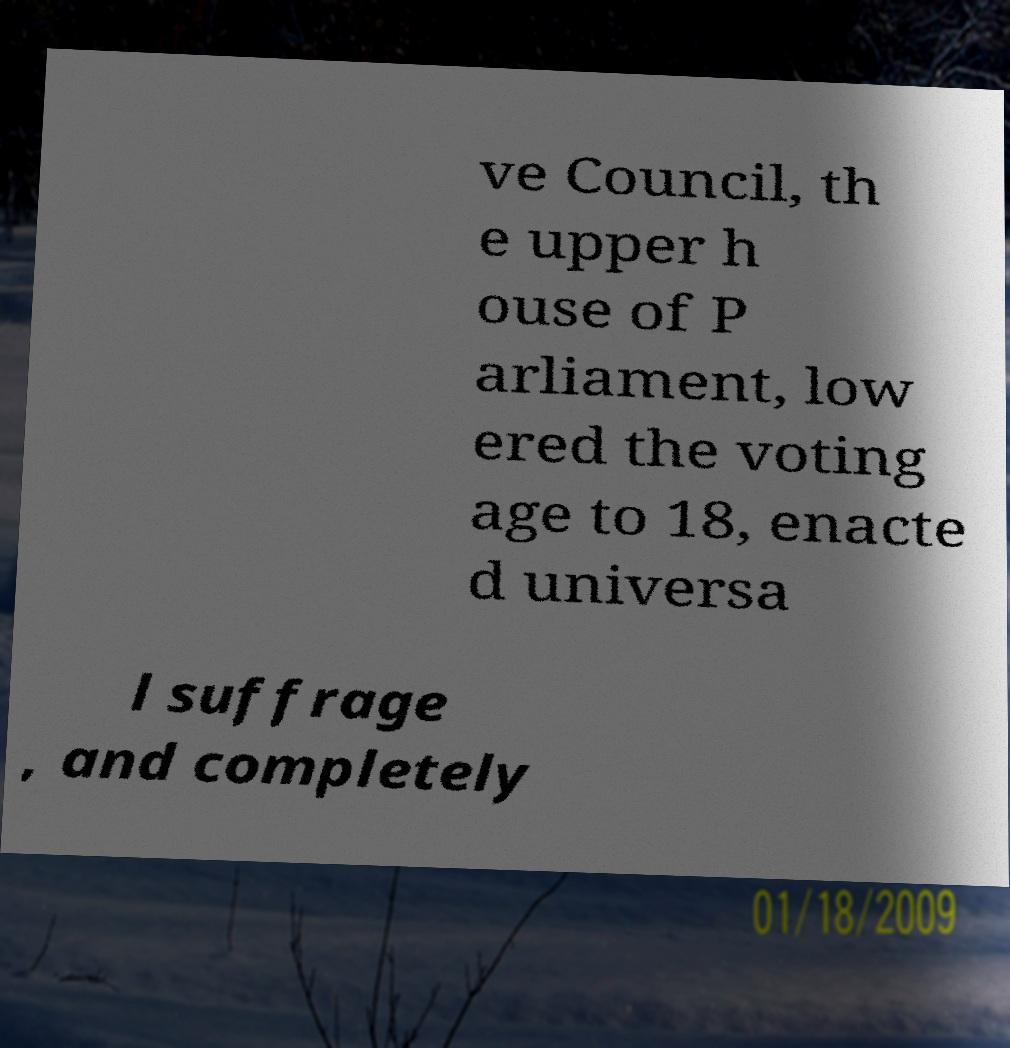Please read and relay the text visible in this image. What does it say? ve Council, th e upper h ouse of P arliament, low ered the voting age to 18, enacte d universa l suffrage , and completely 